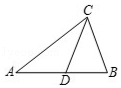What other significant geometrical concepts can be visually interpreted from triangle ABC aside from the median? Triangle ABC offers a rich source for exploring various geometrical concepts such as the bisectors, altitudes, and angle properties. For example, angle bisectors could be discussed, which would split angles at vertices A, B, and C, offering insights into angle properties. Additionally, exploring altitudes, which are perpendicular from a vertex to the opposite side, provides a deeper understanding of orthocentric systems within triangles. 